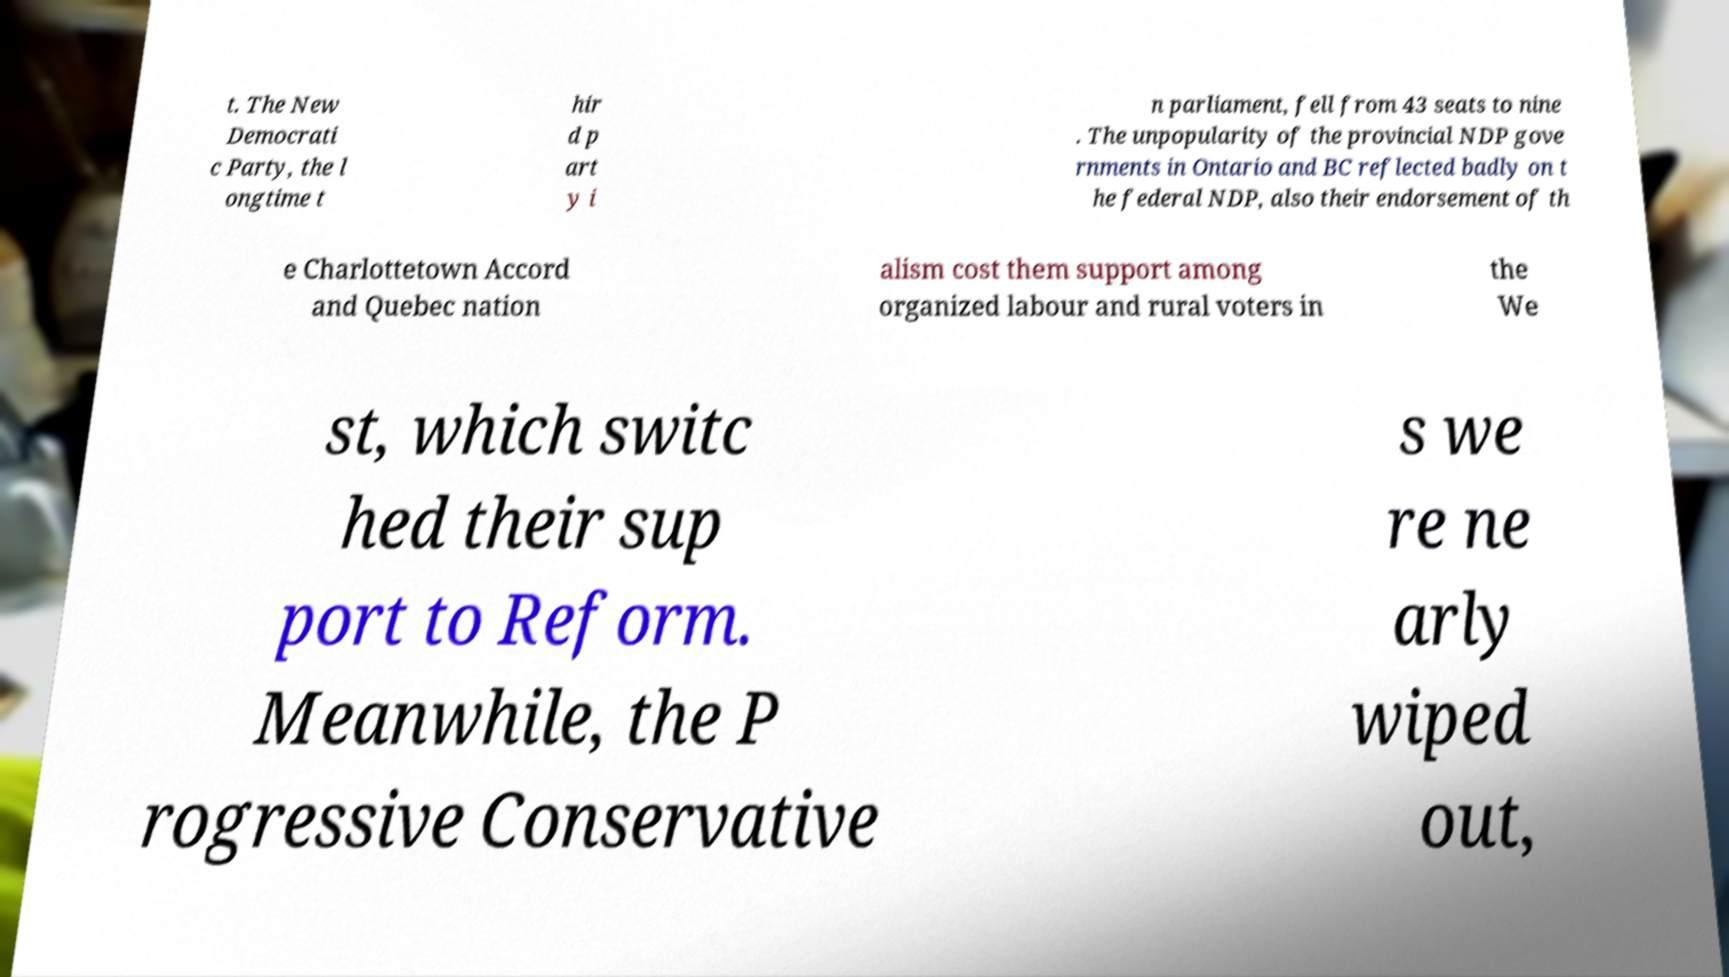Can you accurately transcribe the text from the provided image for me? t. The New Democrati c Party, the l ongtime t hir d p art y i n parliament, fell from 43 seats to nine . The unpopularity of the provincial NDP gove rnments in Ontario and BC reflected badly on t he federal NDP, also their endorsement of th e Charlottetown Accord and Quebec nation alism cost them support among organized labour and rural voters in the We st, which switc hed their sup port to Reform. Meanwhile, the P rogressive Conservative s we re ne arly wiped out, 